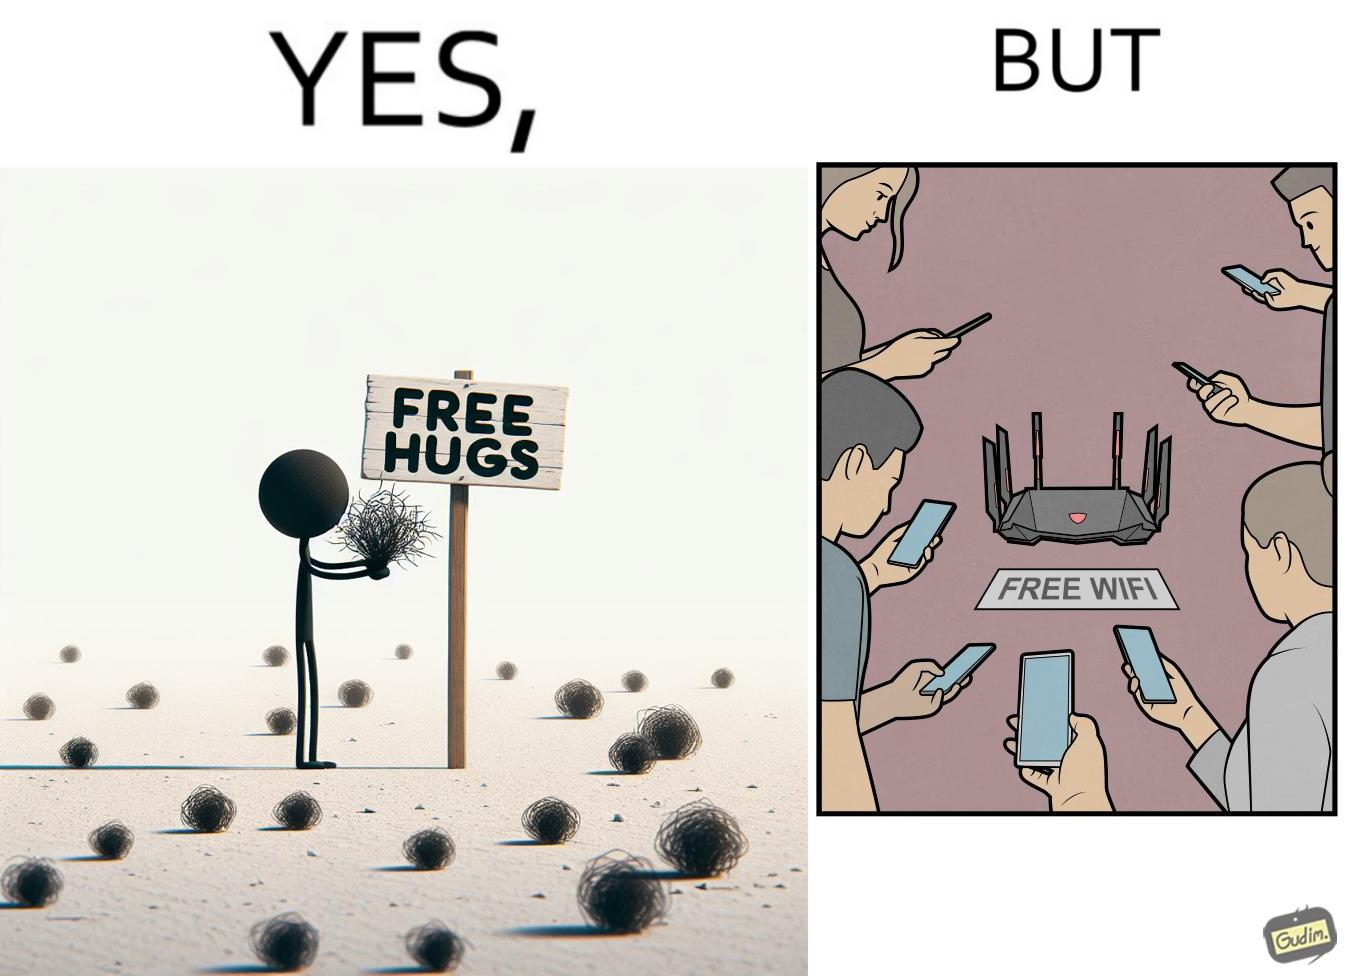Describe the content of this image. This image is ironical, as a person holding up a "Free Hugs" sign is standing alone, while an inanimate Wi-fi Router giving "Free Wifi" is surrounded people trying to connect to it. This shows a growing lack of empathy in our society, while showing our increasing dependence on the digital devices in a virtual world. 